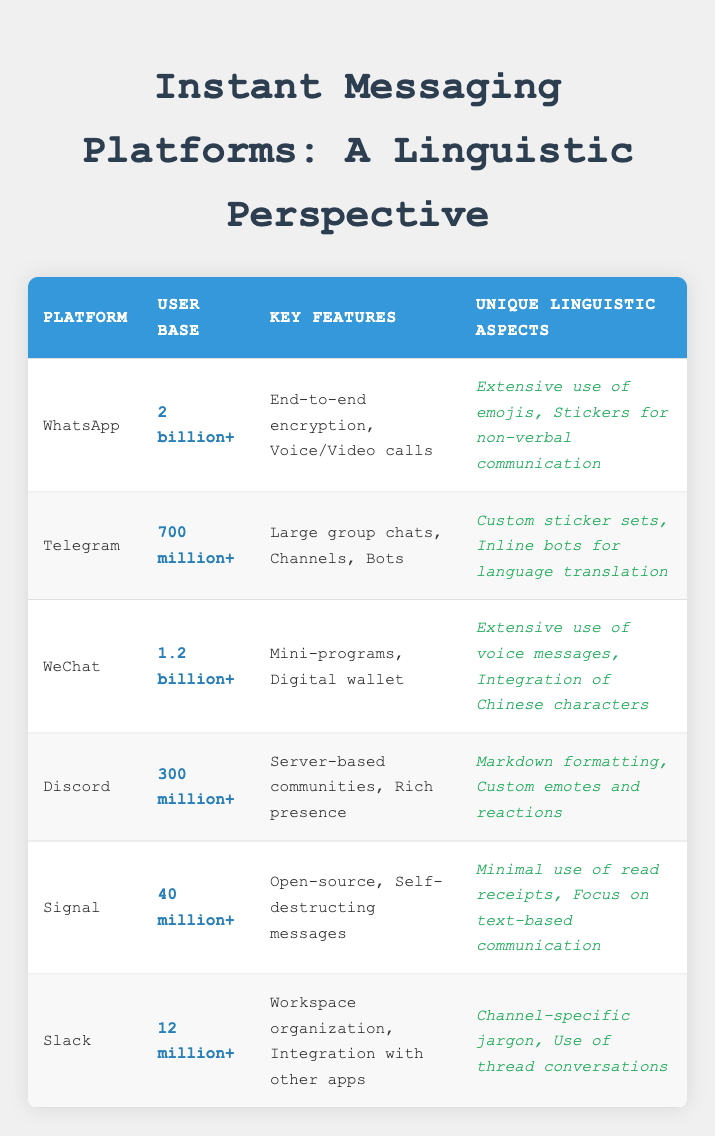What is the user base of Telegram? The table lists the user base of each messaging platform. For Telegram, it is directly stated in the "User Base" column.
Answer: 700 million+ Which platform has the largest user base? To find the largest user base, I can compare the values in the "User Base" column. WhatsApp has the highest value at "2 billion+," making it the largest.
Answer: WhatsApp Does Discord offer end-to-end encryption? From the "Key Features" column, I checked if Discord includes "end-to-end encryption." It does not mention this feature, indicating it is not offered by Discord.
Answer: No Which platform has unique linguistic aspects focused on text-based communication? By examining the "Unique Linguistic Aspects" column, I see that Signal mentions "Focus on text-based communication," indicating this platform emphasizes that aspect.
Answer: Signal What is the difference in user base between WhatsApp and Signal? I need to take the user base of WhatsApp, which is "2 billion+," and Signal, which is "40 million+." To find the difference, I convert them into a comparable format: 2,000 million - 40 million = 1960 million.
Answer: 1960 million Does WeChat utilize any unique linguistic aspects related to Chinese characters? By looking at WeChat’s entry in the "Unique Linguistic Aspects" column, I find it explicitly states "Integration of Chinese characters," confirming this fact.
Answer: Yes How many more key features does Telegram have compared to Slack? The "Key Features" column reveals Telegram has three key features, while Slack has two. The difference is calculated as 3 - 2 = 1.
Answer: 1 Which platform allows for server-based communities and rich presence? I can refer to the "Key Features" column for Discord, which lists "Server-based communities" and "Rich presence," confirming that Discord includes these features.
Answer: Discord What unique aspect does Discord have for emotional expression compared to WhatsApp? By checking the "Unique Linguistic Aspects" for Discord, it states "Custom emotes and reactions," while WhatsApp primarily mentions "Extensive use of emojis." This indicates Discord provides more customizable emotional expressions.
Answer: Discord 